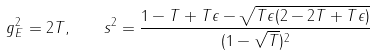Convert formula to latex. <formula><loc_0><loc_0><loc_500><loc_500>g _ { E } ^ { 2 } = 2 T , \quad s ^ { 2 } = \frac { 1 - T + T \epsilon - \sqrt { T \epsilon ( 2 - 2 T + T \epsilon ) } } { ( 1 - \sqrt { T } ) ^ { 2 } }</formula> 